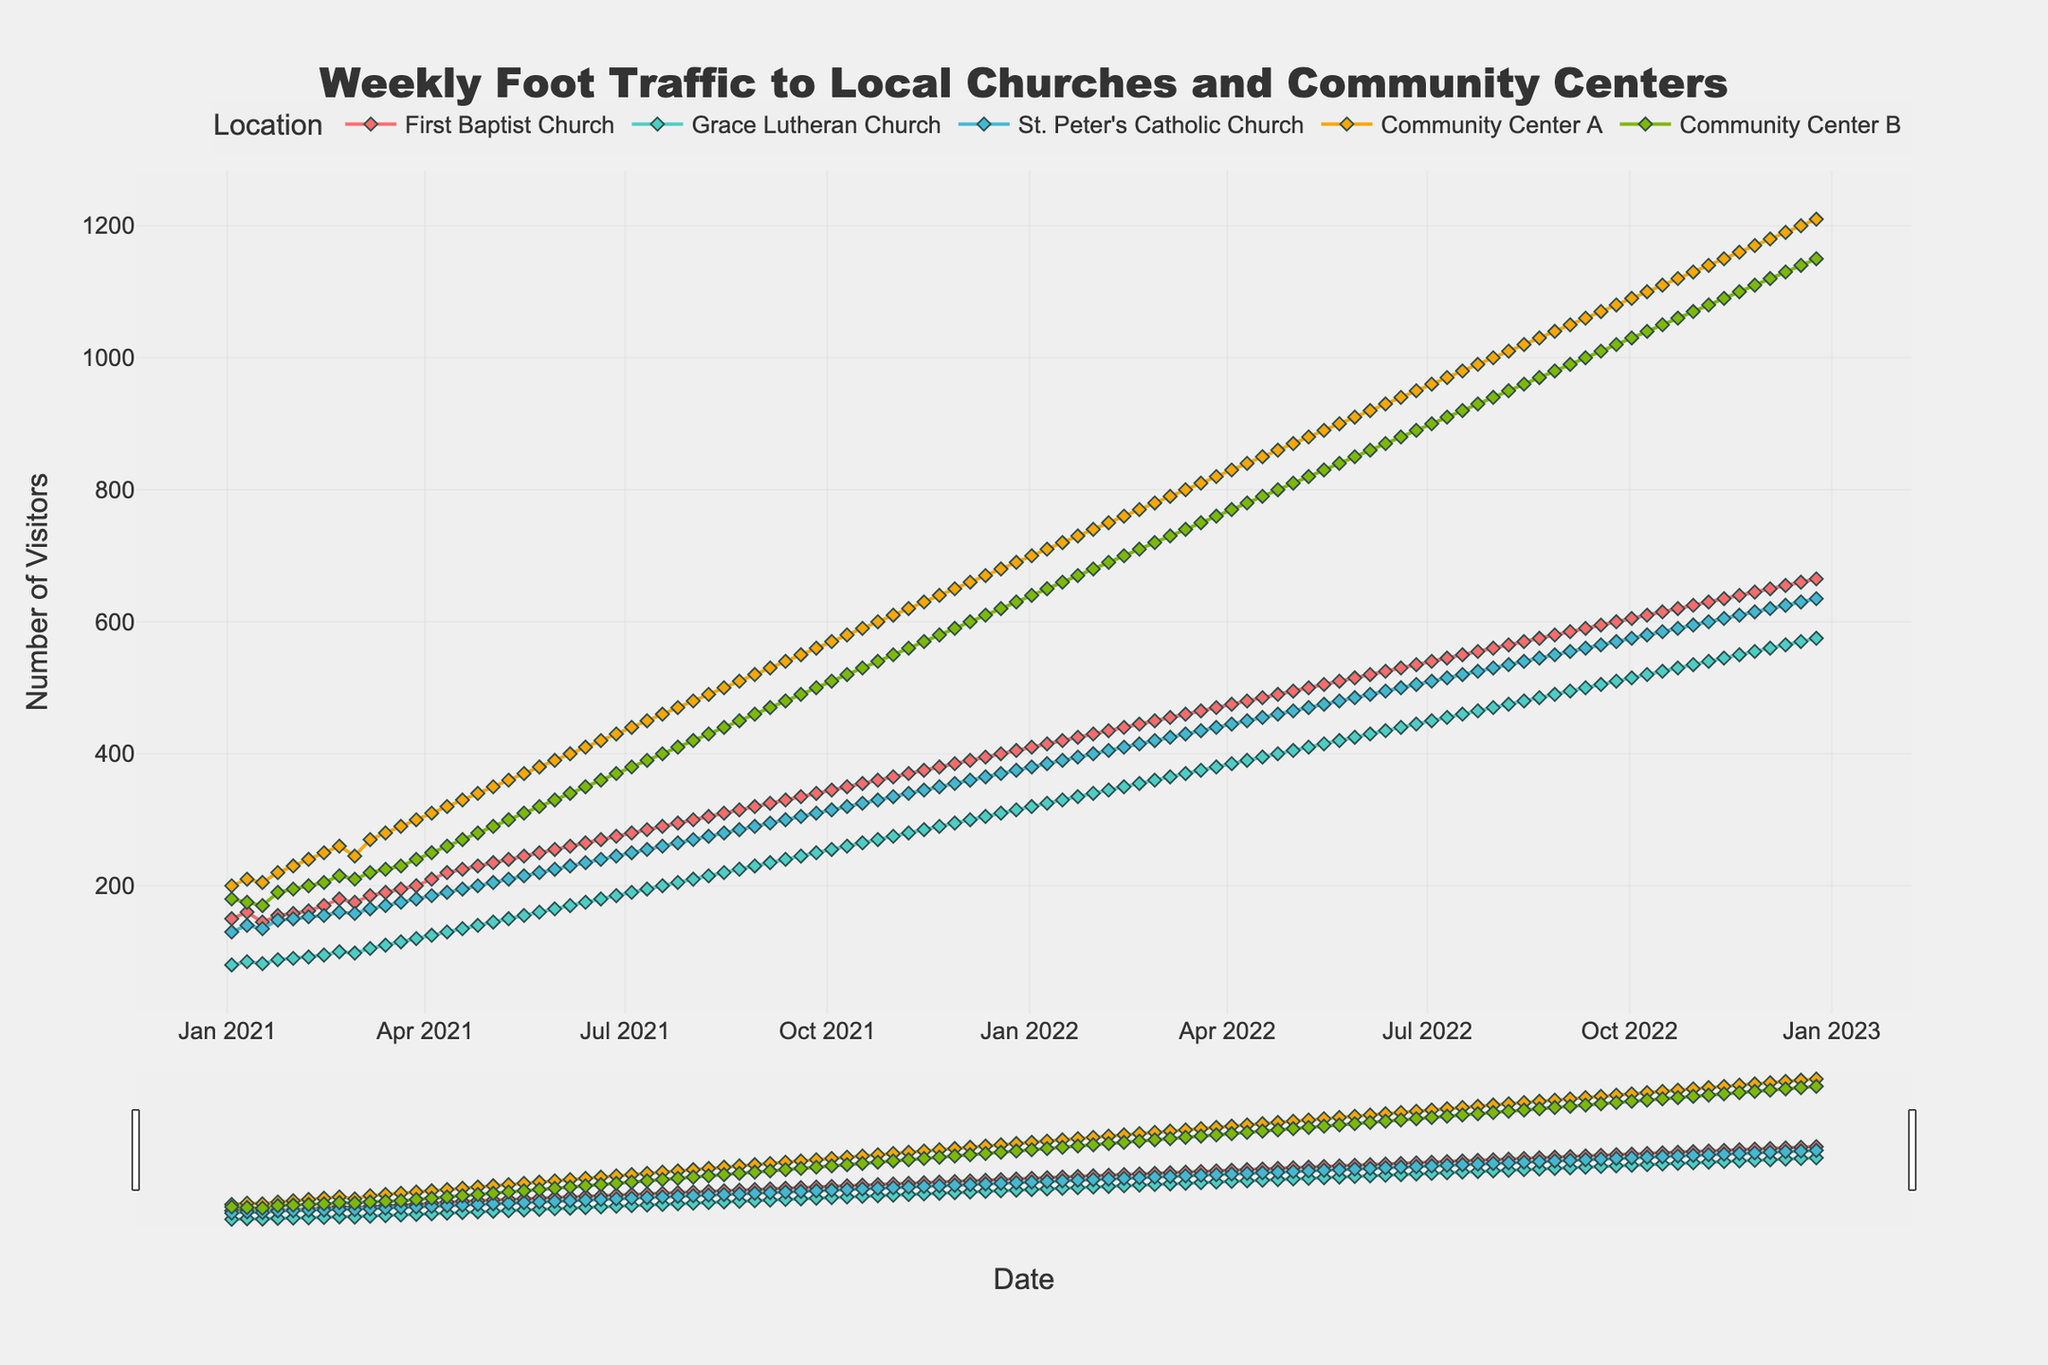What is the title of the plot? The title is displayed at the top of the plot and provides a summary of what the figure represents. The title is "Weekly Foot Traffic to Local Churches and Community Centers."
Answer: Weekly Foot Traffic to Local Churches and Community Centers What locations are represented in the plot? The legend indicates the different locations with distinct markers and colors. The locations include First Baptist Church, Grace Lutheran Church, St. Peter's Catholic Church, Community Center A, and Community Center B.
Answer: First Baptist Church, Grace Lutheran Church, St. Peter's Catholic Church, Community Center A, Community Center B On which date did Community Center A have 650 visitors? By following Community Center A's curve to the point where it intersects the 650 visitors mark, then tracing down to the x-axis, we find the specific date. Community Center A reached 650 visitors on 2021-11-28.
Answer: 2021-11-28 Which place had the highest foot traffic by the end of the period shown? The end of the period shown is 2022-12-25. By looking at the last data points in the plot, Community Center A had the highest foot traffic around 1210 visitors.
Answer: Community Center A How do the visitation trends of Community Center B compare to Grace Lutheran Church over the two years? Community Center B shows a consistently higher and more rapid increase in visitors compared to Grace Lutheran Church. Visibly, the gap widens as the years progress, indicating a higher growth rate in foot traffic for Community Center B.
Answer: Community Center B had more rapid growth What was the increase in foot traffic for St. Peter's Catholic Church from 2021-01-03 to 2022-12-25? St. Peter's Catholic Church started with 130 visitors on 2021-01-03 and ended with 635 visitors on 2022-12-25. The increase is calculated as 635 - 130 = 505 visitors.
Answer: 505 visitors Which location showed the largest fluctuation in the number of visitors over the two years? Fluctuation can be determined by visually estimating the range (difference between highest and lowest points) for each location’s curve. St. Peter's Catholic Church's curve appears to have the smallest variation in contrast to Community Center A, which shows a more dynamic range with higher peaks and troughs.
Answer: Community Center A Did any location experience a decline over the entire period? Examining all curves, we find that none of the curves show a consistent decline from start to finish; they all show growth in foot traffic over both years.
Answer: No If you average the foot traffic of Community Center B in January 2021, what is the result? The values for January 2021 are 180, 175, 170, 190. Summing these gives 715. Dividing by the number of weeks (4), the average is 715 / 4 = 178.75 visitors.
Answer: 178.75 visitors 